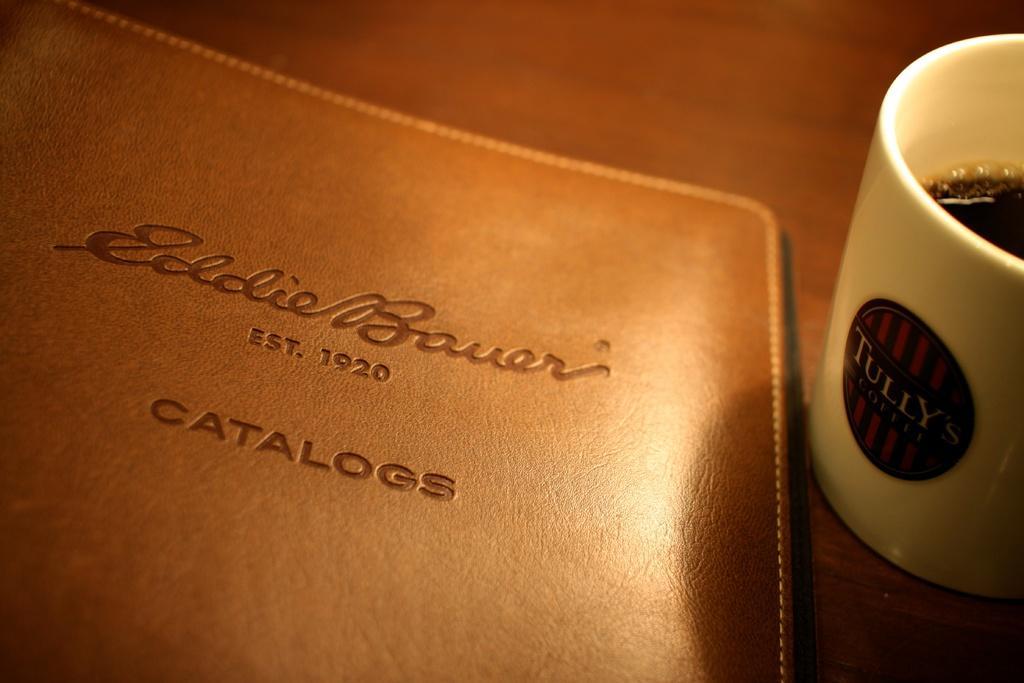Please provide a concise description of this image. On the table I can see the cup and file. In the cup I can see the black tea. 